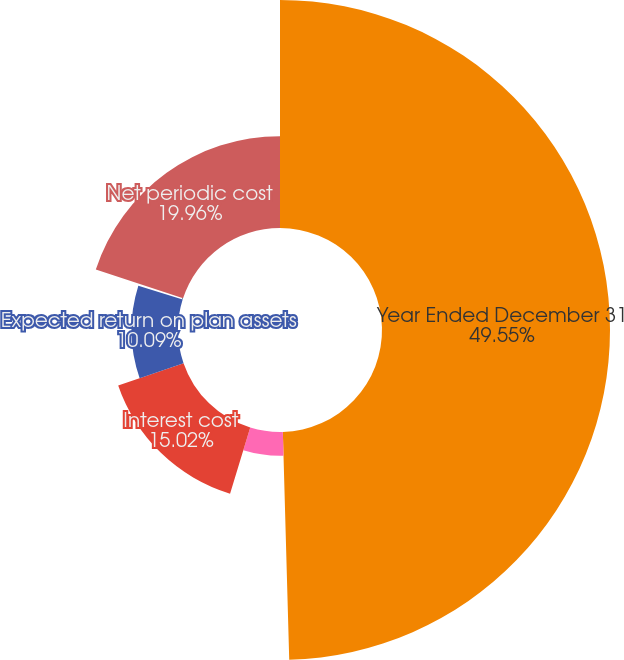Convert chart to OTSL. <chart><loc_0><loc_0><loc_500><loc_500><pie_chart><fcel>Year Ended December 31<fcel>Service cost<fcel>Interest cost<fcel>Expected return on plan assets<fcel>Recognized net actuarial loss<fcel>Net periodic cost<nl><fcel>49.56%<fcel>5.16%<fcel>15.02%<fcel>10.09%<fcel>0.22%<fcel>19.96%<nl></chart> 